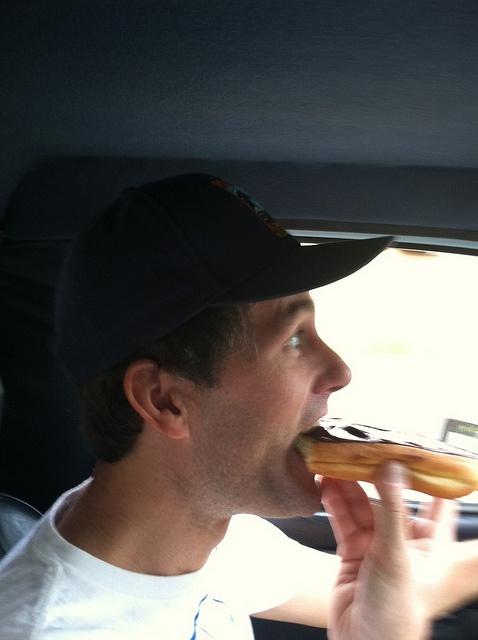Describe the objects in this image and their specific colors. I can see people in black, ivory, and gray tones, sandwich in black, brown, ivory, and tan tones, and pizza in black, brown, ivory, tan, and gray tones in this image. 